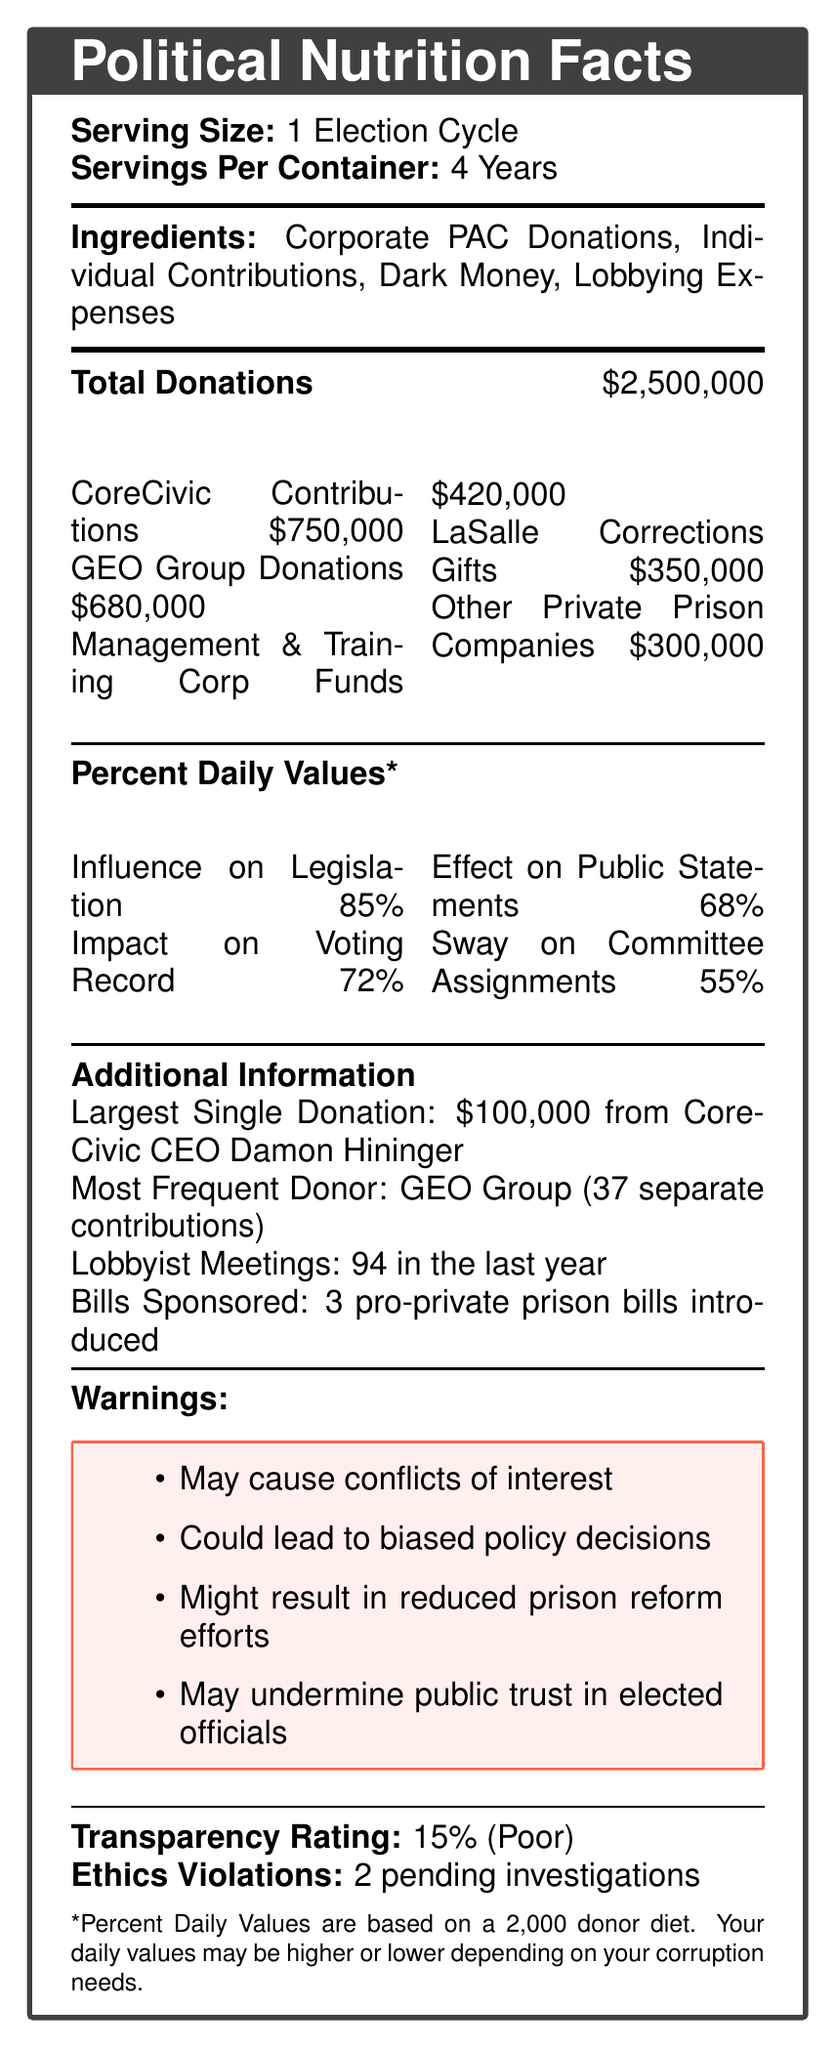what is the serving size mentioned in the document? The document states that the serving size is "1 Election Cycle."
Answer: 1 Election Cycle how many years are there per container as per the document? The document specifies that there are "4 Years" per container.
Answer: 4 Years what are the main ingredients listed in the document? The document lists the main ingredients as "Corporate PAC Donations, Individual Contributions, Dark Money, Lobbying Expenses."
Answer: Corporate PAC Donations, Individual Contributions, Dark Money, Lobbying Expenses what is the total amount of donations received? The document states that the "Total Donations" amount to $2,500,000.
Answer: $2,500,000 who made the largest single donation, and what was the amount? The document mentions that the largest single donation was "$100,000 from CoreCivic CEO Damon Hininger."
Answer: CoreCivic CEO Damon Hininger, $100,000 which company made the most frequent donations? The document indicates that GEO Group is the most frequent donor with "37 separate contributions."
Answer: GEO Group how many lobbying meetings occurred in the last year? The document states that there were "94 lobbying meetings in the last year."
Answer: 94 what percent daily value is attributed to the influence on legislation? The document provides a "Percent Daily Value*" of "85%" for influence on legislation.
Answer: 85% how many pro-private prison bills were introduced according to the document? The document records that "3 pro-private prison bills were introduced."
Answer: 3 what is the transparency rating mentioned in the document? The document mentions a "Transparency Rating: 15% (Poor)."
Answer: 15% (Poor) what are the warnings listed in the document? The document lists the warnings as: "May cause conflicts of interest, Could lead to biased policy decisions, Might result in reduced prison reform efforts, May undermine public trust in elected officials."
Answer: May cause conflicts of interest, Could lead to biased policy decisions, Might result in reduced prison reform efforts, May undermine public trust in elected officials what is the total amount of contributions received from CoreCivic? The document mentions that $750,000 was contributed by CoreCivic.
Answer: $750,000 which company provided the least amount of donations as per the document? A. CoreCivic B. GEO Group C. Management & Training Corp D. LaSalle Corrections E. Other Private Prison Companies The document provides donation amounts, showing that "Other Private Prison Companies" contributed the least with $300,000.
Answer: E what type of bias might result from the donations as mentioned in the document? A. Economic B. Policy C. Ethical D. Social The document includes a warning about biased policy decisions.
Answer: B are there any pending ethics investigations mentioned in the document? The document states "Ethics Violations: 2 pending investigations."
Answer: Yes summarize the main idea of the document. The document is styled as a Nutrition Facts label and includes details on donations from various private prison companies, highlights their influence on political actions, and warns about the resulting ethical and policy implications.
Answer: The document presents a visual representation of the financial ties between a politician and various private prison industry donors, detailing donation amounts, sources, the potential impact on political actions, and associated risks like conflicts of interest and reduced public trust. what is the exact amount donated by LaSalle Corrections? The document provides only the total amounts for several donors but does not break down specifics beyond the largest single donation, frequent donor, and overall totals.
Answer: Not enough information 